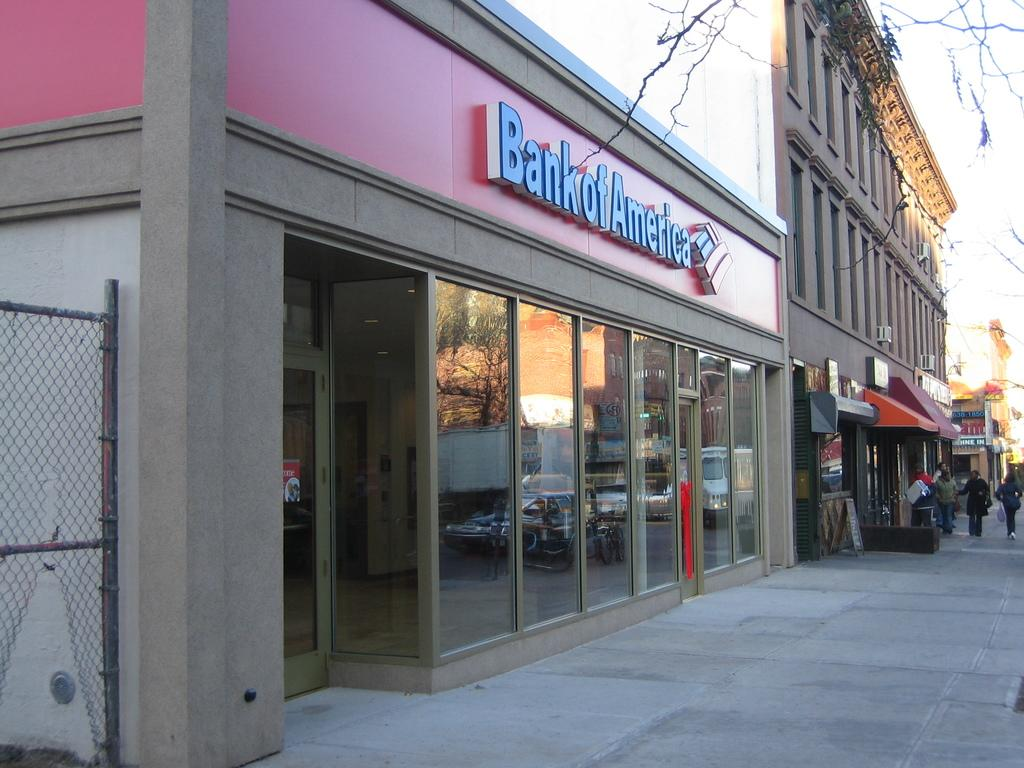<image>
Describe the image concisely. The front of a Bank of America branch. 